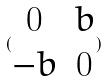<formula> <loc_0><loc_0><loc_500><loc_500>( \begin{matrix} 0 & b \\ - b & 0 \end{matrix} )</formula> 